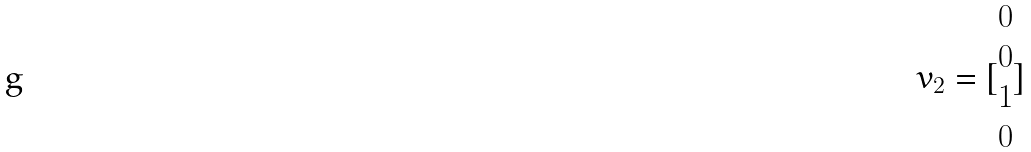Convert formula to latex. <formula><loc_0><loc_0><loc_500><loc_500>v _ { 2 } = [ \begin{matrix} 0 \\ 0 \\ 1 \\ 0 \end{matrix} ]</formula> 